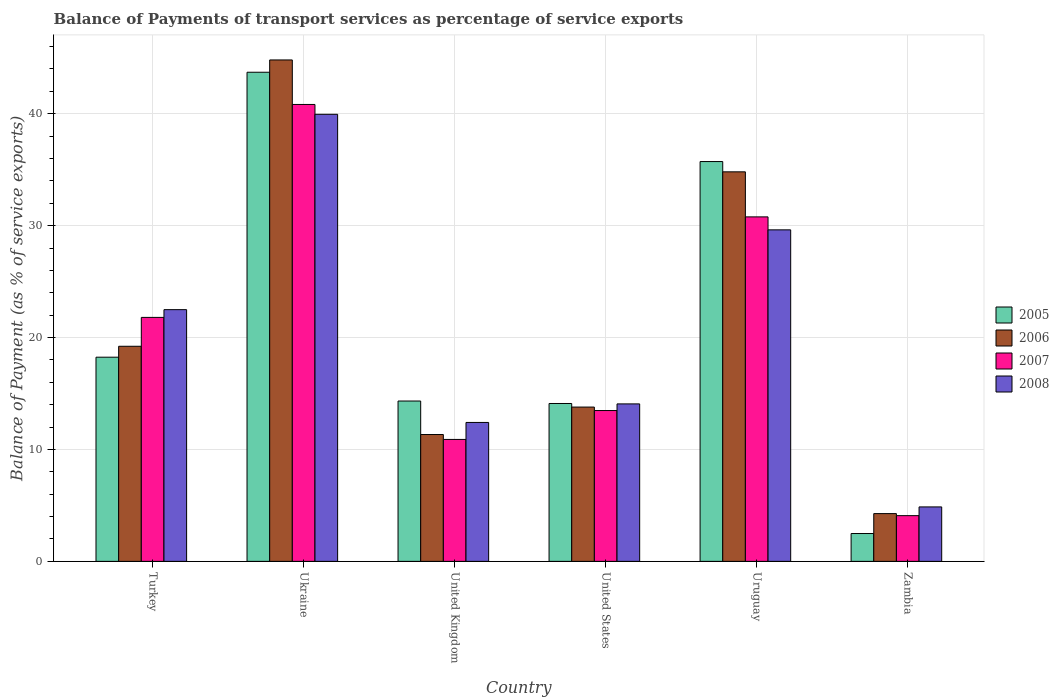How many different coloured bars are there?
Make the answer very short. 4. Are the number of bars on each tick of the X-axis equal?
Offer a very short reply. Yes. How many bars are there on the 5th tick from the left?
Provide a succinct answer. 4. How many bars are there on the 5th tick from the right?
Your answer should be compact. 4. What is the label of the 3rd group of bars from the left?
Your answer should be very brief. United Kingdom. In how many cases, is the number of bars for a given country not equal to the number of legend labels?
Offer a terse response. 0. What is the balance of payments of transport services in 2007 in United States?
Provide a short and direct response. 13.48. Across all countries, what is the maximum balance of payments of transport services in 2006?
Keep it short and to the point. 44.81. Across all countries, what is the minimum balance of payments of transport services in 2005?
Give a very brief answer. 2.49. In which country was the balance of payments of transport services in 2006 maximum?
Offer a very short reply. Ukraine. In which country was the balance of payments of transport services in 2008 minimum?
Keep it short and to the point. Zambia. What is the total balance of payments of transport services in 2006 in the graph?
Offer a very short reply. 128.23. What is the difference between the balance of payments of transport services in 2007 in Uruguay and that in Zambia?
Provide a short and direct response. 26.7. What is the difference between the balance of payments of transport services in 2008 in Turkey and the balance of payments of transport services in 2007 in United States?
Offer a terse response. 9.02. What is the average balance of payments of transport services in 2008 per country?
Offer a very short reply. 20.57. What is the difference between the balance of payments of transport services of/in 2008 and balance of payments of transport services of/in 2006 in Zambia?
Ensure brevity in your answer.  0.6. What is the ratio of the balance of payments of transport services in 2008 in United Kingdom to that in Zambia?
Make the answer very short. 2.55. What is the difference between the highest and the second highest balance of payments of transport services in 2005?
Provide a short and direct response. 17.48. What is the difference between the highest and the lowest balance of payments of transport services in 2005?
Ensure brevity in your answer.  41.22. In how many countries, is the balance of payments of transport services in 2007 greater than the average balance of payments of transport services in 2007 taken over all countries?
Offer a very short reply. 3. Is it the case that in every country, the sum of the balance of payments of transport services in 2005 and balance of payments of transport services in 2007 is greater than the sum of balance of payments of transport services in 2006 and balance of payments of transport services in 2008?
Keep it short and to the point. No. What does the 3rd bar from the right in Zambia represents?
Keep it short and to the point. 2006. How many bars are there?
Make the answer very short. 24. Are all the bars in the graph horizontal?
Give a very brief answer. No. Where does the legend appear in the graph?
Provide a succinct answer. Center right. How many legend labels are there?
Make the answer very short. 4. How are the legend labels stacked?
Make the answer very short. Vertical. What is the title of the graph?
Make the answer very short. Balance of Payments of transport services as percentage of service exports. What is the label or title of the Y-axis?
Your answer should be very brief. Balance of Payment (as % of service exports). What is the Balance of Payment (as % of service exports) in 2005 in Turkey?
Ensure brevity in your answer.  18.24. What is the Balance of Payment (as % of service exports) of 2006 in Turkey?
Your answer should be very brief. 19.22. What is the Balance of Payment (as % of service exports) in 2007 in Turkey?
Keep it short and to the point. 21.8. What is the Balance of Payment (as % of service exports) of 2008 in Turkey?
Provide a succinct answer. 22.49. What is the Balance of Payment (as % of service exports) in 2005 in Ukraine?
Make the answer very short. 43.71. What is the Balance of Payment (as % of service exports) of 2006 in Ukraine?
Your response must be concise. 44.81. What is the Balance of Payment (as % of service exports) in 2007 in Ukraine?
Give a very brief answer. 40.83. What is the Balance of Payment (as % of service exports) in 2008 in Ukraine?
Make the answer very short. 39.95. What is the Balance of Payment (as % of service exports) of 2005 in United Kingdom?
Ensure brevity in your answer.  14.33. What is the Balance of Payment (as % of service exports) in 2006 in United Kingdom?
Make the answer very short. 11.33. What is the Balance of Payment (as % of service exports) in 2007 in United Kingdom?
Ensure brevity in your answer.  10.9. What is the Balance of Payment (as % of service exports) in 2008 in United Kingdom?
Your answer should be compact. 12.41. What is the Balance of Payment (as % of service exports) of 2005 in United States?
Your answer should be very brief. 14.11. What is the Balance of Payment (as % of service exports) of 2006 in United States?
Ensure brevity in your answer.  13.79. What is the Balance of Payment (as % of service exports) of 2007 in United States?
Give a very brief answer. 13.48. What is the Balance of Payment (as % of service exports) in 2008 in United States?
Your answer should be very brief. 14.07. What is the Balance of Payment (as % of service exports) of 2005 in Uruguay?
Give a very brief answer. 35.73. What is the Balance of Payment (as % of service exports) of 2006 in Uruguay?
Offer a very short reply. 34.81. What is the Balance of Payment (as % of service exports) of 2007 in Uruguay?
Your answer should be compact. 30.78. What is the Balance of Payment (as % of service exports) of 2008 in Uruguay?
Offer a terse response. 29.62. What is the Balance of Payment (as % of service exports) of 2005 in Zambia?
Keep it short and to the point. 2.49. What is the Balance of Payment (as % of service exports) in 2006 in Zambia?
Your answer should be compact. 4.27. What is the Balance of Payment (as % of service exports) in 2007 in Zambia?
Your response must be concise. 4.08. What is the Balance of Payment (as % of service exports) of 2008 in Zambia?
Ensure brevity in your answer.  4.87. Across all countries, what is the maximum Balance of Payment (as % of service exports) of 2005?
Offer a terse response. 43.71. Across all countries, what is the maximum Balance of Payment (as % of service exports) in 2006?
Make the answer very short. 44.81. Across all countries, what is the maximum Balance of Payment (as % of service exports) in 2007?
Keep it short and to the point. 40.83. Across all countries, what is the maximum Balance of Payment (as % of service exports) of 2008?
Your response must be concise. 39.95. Across all countries, what is the minimum Balance of Payment (as % of service exports) in 2005?
Make the answer very short. 2.49. Across all countries, what is the minimum Balance of Payment (as % of service exports) of 2006?
Provide a short and direct response. 4.27. Across all countries, what is the minimum Balance of Payment (as % of service exports) in 2007?
Your answer should be very brief. 4.08. Across all countries, what is the minimum Balance of Payment (as % of service exports) of 2008?
Make the answer very short. 4.87. What is the total Balance of Payment (as % of service exports) of 2005 in the graph?
Make the answer very short. 128.6. What is the total Balance of Payment (as % of service exports) of 2006 in the graph?
Offer a terse response. 128.23. What is the total Balance of Payment (as % of service exports) in 2007 in the graph?
Give a very brief answer. 121.87. What is the total Balance of Payment (as % of service exports) in 2008 in the graph?
Your answer should be compact. 123.42. What is the difference between the Balance of Payment (as % of service exports) in 2005 in Turkey and that in Ukraine?
Offer a very short reply. -25.46. What is the difference between the Balance of Payment (as % of service exports) of 2006 in Turkey and that in Ukraine?
Provide a short and direct response. -25.59. What is the difference between the Balance of Payment (as % of service exports) in 2007 in Turkey and that in Ukraine?
Ensure brevity in your answer.  -19.03. What is the difference between the Balance of Payment (as % of service exports) in 2008 in Turkey and that in Ukraine?
Keep it short and to the point. -17.46. What is the difference between the Balance of Payment (as % of service exports) in 2005 in Turkey and that in United Kingdom?
Keep it short and to the point. 3.92. What is the difference between the Balance of Payment (as % of service exports) in 2006 in Turkey and that in United Kingdom?
Your response must be concise. 7.89. What is the difference between the Balance of Payment (as % of service exports) in 2007 in Turkey and that in United Kingdom?
Make the answer very short. 10.9. What is the difference between the Balance of Payment (as % of service exports) in 2008 in Turkey and that in United Kingdom?
Offer a terse response. 10.08. What is the difference between the Balance of Payment (as % of service exports) of 2005 in Turkey and that in United States?
Ensure brevity in your answer.  4.14. What is the difference between the Balance of Payment (as % of service exports) of 2006 in Turkey and that in United States?
Keep it short and to the point. 5.43. What is the difference between the Balance of Payment (as % of service exports) of 2007 in Turkey and that in United States?
Provide a succinct answer. 8.32. What is the difference between the Balance of Payment (as % of service exports) of 2008 in Turkey and that in United States?
Keep it short and to the point. 8.42. What is the difference between the Balance of Payment (as % of service exports) of 2005 in Turkey and that in Uruguay?
Offer a very short reply. -17.48. What is the difference between the Balance of Payment (as % of service exports) in 2006 in Turkey and that in Uruguay?
Give a very brief answer. -15.59. What is the difference between the Balance of Payment (as % of service exports) of 2007 in Turkey and that in Uruguay?
Give a very brief answer. -8.98. What is the difference between the Balance of Payment (as % of service exports) of 2008 in Turkey and that in Uruguay?
Your answer should be compact. -7.13. What is the difference between the Balance of Payment (as % of service exports) of 2005 in Turkey and that in Zambia?
Your answer should be compact. 15.76. What is the difference between the Balance of Payment (as % of service exports) of 2006 in Turkey and that in Zambia?
Provide a succinct answer. 14.95. What is the difference between the Balance of Payment (as % of service exports) of 2007 in Turkey and that in Zambia?
Make the answer very short. 17.72. What is the difference between the Balance of Payment (as % of service exports) of 2008 in Turkey and that in Zambia?
Provide a short and direct response. 17.63. What is the difference between the Balance of Payment (as % of service exports) in 2005 in Ukraine and that in United Kingdom?
Provide a succinct answer. 29.38. What is the difference between the Balance of Payment (as % of service exports) of 2006 in Ukraine and that in United Kingdom?
Provide a succinct answer. 33.47. What is the difference between the Balance of Payment (as % of service exports) of 2007 in Ukraine and that in United Kingdom?
Offer a terse response. 29.93. What is the difference between the Balance of Payment (as % of service exports) of 2008 in Ukraine and that in United Kingdom?
Provide a short and direct response. 27.54. What is the difference between the Balance of Payment (as % of service exports) of 2005 in Ukraine and that in United States?
Offer a terse response. 29.6. What is the difference between the Balance of Payment (as % of service exports) of 2006 in Ukraine and that in United States?
Offer a very short reply. 31.02. What is the difference between the Balance of Payment (as % of service exports) in 2007 in Ukraine and that in United States?
Make the answer very short. 27.35. What is the difference between the Balance of Payment (as % of service exports) of 2008 in Ukraine and that in United States?
Your response must be concise. 25.88. What is the difference between the Balance of Payment (as % of service exports) in 2005 in Ukraine and that in Uruguay?
Your response must be concise. 7.98. What is the difference between the Balance of Payment (as % of service exports) of 2006 in Ukraine and that in Uruguay?
Your response must be concise. 10. What is the difference between the Balance of Payment (as % of service exports) of 2007 in Ukraine and that in Uruguay?
Provide a succinct answer. 10.05. What is the difference between the Balance of Payment (as % of service exports) in 2008 in Ukraine and that in Uruguay?
Give a very brief answer. 10.32. What is the difference between the Balance of Payment (as % of service exports) of 2005 in Ukraine and that in Zambia?
Offer a terse response. 41.22. What is the difference between the Balance of Payment (as % of service exports) in 2006 in Ukraine and that in Zambia?
Give a very brief answer. 40.54. What is the difference between the Balance of Payment (as % of service exports) of 2007 in Ukraine and that in Zambia?
Ensure brevity in your answer.  36.74. What is the difference between the Balance of Payment (as % of service exports) of 2008 in Ukraine and that in Zambia?
Ensure brevity in your answer.  35.08. What is the difference between the Balance of Payment (as % of service exports) in 2005 in United Kingdom and that in United States?
Your answer should be compact. 0.22. What is the difference between the Balance of Payment (as % of service exports) in 2006 in United Kingdom and that in United States?
Offer a very short reply. -2.45. What is the difference between the Balance of Payment (as % of service exports) of 2007 in United Kingdom and that in United States?
Your answer should be very brief. -2.58. What is the difference between the Balance of Payment (as % of service exports) of 2008 in United Kingdom and that in United States?
Offer a terse response. -1.66. What is the difference between the Balance of Payment (as % of service exports) in 2005 in United Kingdom and that in Uruguay?
Provide a succinct answer. -21.4. What is the difference between the Balance of Payment (as % of service exports) in 2006 in United Kingdom and that in Uruguay?
Give a very brief answer. -23.47. What is the difference between the Balance of Payment (as % of service exports) of 2007 in United Kingdom and that in Uruguay?
Your answer should be compact. -19.89. What is the difference between the Balance of Payment (as % of service exports) of 2008 in United Kingdom and that in Uruguay?
Provide a short and direct response. -17.21. What is the difference between the Balance of Payment (as % of service exports) in 2005 in United Kingdom and that in Zambia?
Your answer should be compact. 11.84. What is the difference between the Balance of Payment (as % of service exports) in 2006 in United Kingdom and that in Zambia?
Offer a terse response. 7.07. What is the difference between the Balance of Payment (as % of service exports) of 2007 in United Kingdom and that in Zambia?
Your answer should be very brief. 6.81. What is the difference between the Balance of Payment (as % of service exports) in 2008 in United Kingdom and that in Zambia?
Ensure brevity in your answer.  7.55. What is the difference between the Balance of Payment (as % of service exports) of 2005 in United States and that in Uruguay?
Your answer should be compact. -21.62. What is the difference between the Balance of Payment (as % of service exports) of 2006 in United States and that in Uruguay?
Offer a terse response. -21.02. What is the difference between the Balance of Payment (as % of service exports) in 2007 in United States and that in Uruguay?
Offer a terse response. -17.31. What is the difference between the Balance of Payment (as % of service exports) of 2008 in United States and that in Uruguay?
Your response must be concise. -15.55. What is the difference between the Balance of Payment (as % of service exports) of 2005 in United States and that in Zambia?
Ensure brevity in your answer.  11.62. What is the difference between the Balance of Payment (as % of service exports) of 2006 in United States and that in Zambia?
Provide a short and direct response. 9.52. What is the difference between the Balance of Payment (as % of service exports) in 2007 in United States and that in Zambia?
Your response must be concise. 9.39. What is the difference between the Balance of Payment (as % of service exports) of 2008 in United States and that in Zambia?
Give a very brief answer. 9.2. What is the difference between the Balance of Payment (as % of service exports) in 2005 in Uruguay and that in Zambia?
Ensure brevity in your answer.  33.24. What is the difference between the Balance of Payment (as % of service exports) in 2006 in Uruguay and that in Zambia?
Your answer should be very brief. 30.54. What is the difference between the Balance of Payment (as % of service exports) of 2007 in Uruguay and that in Zambia?
Your answer should be very brief. 26.7. What is the difference between the Balance of Payment (as % of service exports) of 2008 in Uruguay and that in Zambia?
Keep it short and to the point. 24.76. What is the difference between the Balance of Payment (as % of service exports) of 2005 in Turkey and the Balance of Payment (as % of service exports) of 2006 in Ukraine?
Provide a succinct answer. -26.56. What is the difference between the Balance of Payment (as % of service exports) of 2005 in Turkey and the Balance of Payment (as % of service exports) of 2007 in Ukraine?
Keep it short and to the point. -22.58. What is the difference between the Balance of Payment (as % of service exports) of 2005 in Turkey and the Balance of Payment (as % of service exports) of 2008 in Ukraine?
Offer a terse response. -21.7. What is the difference between the Balance of Payment (as % of service exports) in 2006 in Turkey and the Balance of Payment (as % of service exports) in 2007 in Ukraine?
Your answer should be compact. -21.61. What is the difference between the Balance of Payment (as % of service exports) in 2006 in Turkey and the Balance of Payment (as % of service exports) in 2008 in Ukraine?
Make the answer very short. -20.73. What is the difference between the Balance of Payment (as % of service exports) in 2007 in Turkey and the Balance of Payment (as % of service exports) in 2008 in Ukraine?
Make the answer very short. -18.15. What is the difference between the Balance of Payment (as % of service exports) of 2005 in Turkey and the Balance of Payment (as % of service exports) of 2006 in United Kingdom?
Make the answer very short. 6.91. What is the difference between the Balance of Payment (as % of service exports) in 2005 in Turkey and the Balance of Payment (as % of service exports) in 2007 in United Kingdom?
Provide a succinct answer. 7.35. What is the difference between the Balance of Payment (as % of service exports) in 2005 in Turkey and the Balance of Payment (as % of service exports) in 2008 in United Kingdom?
Provide a short and direct response. 5.83. What is the difference between the Balance of Payment (as % of service exports) of 2006 in Turkey and the Balance of Payment (as % of service exports) of 2007 in United Kingdom?
Ensure brevity in your answer.  8.32. What is the difference between the Balance of Payment (as % of service exports) of 2006 in Turkey and the Balance of Payment (as % of service exports) of 2008 in United Kingdom?
Offer a terse response. 6.81. What is the difference between the Balance of Payment (as % of service exports) in 2007 in Turkey and the Balance of Payment (as % of service exports) in 2008 in United Kingdom?
Ensure brevity in your answer.  9.39. What is the difference between the Balance of Payment (as % of service exports) in 2005 in Turkey and the Balance of Payment (as % of service exports) in 2006 in United States?
Make the answer very short. 4.46. What is the difference between the Balance of Payment (as % of service exports) of 2005 in Turkey and the Balance of Payment (as % of service exports) of 2007 in United States?
Provide a short and direct response. 4.77. What is the difference between the Balance of Payment (as % of service exports) in 2005 in Turkey and the Balance of Payment (as % of service exports) in 2008 in United States?
Provide a succinct answer. 4.17. What is the difference between the Balance of Payment (as % of service exports) of 2006 in Turkey and the Balance of Payment (as % of service exports) of 2007 in United States?
Ensure brevity in your answer.  5.74. What is the difference between the Balance of Payment (as % of service exports) of 2006 in Turkey and the Balance of Payment (as % of service exports) of 2008 in United States?
Your answer should be very brief. 5.15. What is the difference between the Balance of Payment (as % of service exports) of 2007 in Turkey and the Balance of Payment (as % of service exports) of 2008 in United States?
Offer a terse response. 7.73. What is the difference between the Balance of Payment (as % of service exports) in 2005 in Turkey and the Balance of Payment (as % of service exports) in 2006 in Uruguay?
Keep it short and to the point. -16.56. What is the difference between the Balance of Payment (as % of service exports) of 2005 in Turkey and the Balance of Payment (as % of service exports) of 2007 in Uruguay?
Give a very brief answer. -12.54. What is the difference between the Balance of Payment (as % of service exports) of 2005 in Turkey and the Balance of Payment (as % of service exports) of 2008 in Uruguay?
Your answer should be compact. -11.38. What is the difference between the Balance of Payment (as % of service exports) in 2006 in Turkey and the Balance of Payment (as % of service exports) in 2007 in Uruguay?
Offer a very short reply. -11.56. What is the difference between the Balance of Payment (as % of service exports) of 2006 in Turkey and the Balance of Payment (as % of service exports) of 2008 in Uruguay?
Ensure brevity in your answer.  -10.4. What is the difference between the Balance of Payment (as % of service exports) in 2007 in Turkey and the Balance of Payment (as % of service exports) in 2008 in Uruguay?
Your answer should be compact. -7.82. What is the difference between the Balance of Payment (as % of service exports) of 2005 in Turkey and the Balance of Payment (as % of service exports) of 2006 in Zambia?
Your answer should be compact. 13.98. What is the difference between the Balance of Payment (as % of service exports) of 2005 in Turkey and the Balance of Payment (as % of service exports) of 2007 in Zambia?
Provide a succinct answer. 14.16. What is the difference between the Balance of Payment (as % of service exports) in 2005 in Turkey and the Balance of Payment (as % of service exports) in 2008 in Zambia?
Give a very brief answer. 13.38. What is the difference between the Balance of Payment (as % of service exports) of 2006 in Turkey and the Balance of Payment (as % of service exports) of 2007 in Zambia?
Provide a short and direct response. 15.14. What is the difference between the Balance of Payment (as % of service exports) in 2006 in Turkey and the Balance of Payment (as % of service exports) in 2008 in Zambia?
Provide a short and direct response. 14.35. What is the difference between the Balance of Payment (as % of service exports) of 2007 in Turkey and the Balance of Payment (as % of service exports) of 2008 in Zambia?
Make the answer very short. 16.93. What is the difference between the Balance of Payment (as % of service exports) of 2005 in Ukraine and the Balance of Payment (as % of service exports) of 2006 in United Kingdom?
Your answer should be very brief. 32.37. What is the difference between the Balance of Payment (as % of service exports) in 2005 in Ukraine and the Balance of Payment (as % of service exports) in 2007 in United Kingdom?
Ensure brevity in your answer.  32.81. What is the difference between the Balance of Payment (as % of service exports) in 2005 in Ukraine and the Balance of Payment (as % of service exports) in 2008 in United Kingdom?
Make the answer very short. 31.29. What is the difference between the Balance of Payment (as % of service exports) of 2006 in Ukraine and the Balance of Payment (as % of service exports) of 2007 in United Kingdom?
Offer a terse response. 33.91. What is the difference between the Balance of Payment (as % of service exports) in 2006 in Ukraine and the Balance of Payment (as % of service exports) in 2008 in United Kingdom?
Keep it short and to the point. 32.39. What is the difference between the Balance of Payment (as % of service exports) in 2007 in Ukraine and the Balance of Payment (as % of service exports) in 2008 in United Kingdom?
Your response must be concise. 28.41. What is the difference between the Balance of Payment (as % of service exports) of 2005 in Ukraine and the Balance of Payment (as % of service exports) of 2006 in United States?
Give a very brief answer. 29.92. What is the difference between the Balance of Payment (as % of service exports) in 2005 in Ukraine and the Balance of Payment (as % of service exports) in 2007 in United States?
Your answer should be very brief. 30.23. What is the difference between the Balance of Payment (as % of service exports) in 2005 in Ukraine and the Balance of Payment (as % of service exports) in 2008 in United States?
Your response must be concise. 29.64. What is the difference between the Balance of Payment (as % of service exports) in 2006 in Ukraine and the Balance of Payment (as % of service exports) in 2007 in United States?
Ensure brevity in your answer.  31.33. What is the difference between the Balance of Payment (as % of service exports) of 2006 in Ukraine and the Balance of Payment (as % of service exports) of 2008 in United States?
Provide a short and direct response. 30.74. What is the difference between the Balance of Payment (as % of service exports) of 2007 in Ukraine and the Balance of Payment (as % of service exports) of 2008 in United States?
Your response must be concise. 26.76. What is the difference between the Balance of Payment (as % of service exports) in 2005 in Ukraine and the Balance of Payment (as % of service exports) in 2006 in Uruguay?
Your response must be concise. 8.9. What is the difference between the Balance of Payment (as % of service exports) of 2005 in Ukraine and the Balance of Payment (as % of service exports) of 2007 in Uruguay?
Your answer should be very brief. 12.93. What is the difference between the Balance of Payment (as % of service exports) of 2005 in Ukraine and the Balance of Payment (as % of service exports) of 2008 in Uruguay?
Your answer should be very brief. 14.08. What is the difference between the Balance of Payment (as % of service exports) of 2006 in Ukraine and the Balance of Payment (as % of service exports) of 2007 in Uruguay?
Make the answer very short. 14.02. What is the difference between the Balance of Payment (as % of service exports) of 2006 in Ukraine and the Balance of Payment (as % of service exports) of 2008 in Uruguay?
Give a very brief answer. 15.18. What is the difference between the Balance of Payment (as % of service exports) of 2007 in Ukraine and the Balance of Payment (as % of service exports) of 2008 in Uruguay?
Keep it short and to the point. 11.21. What is the difference between the Balance of Payment (as % of service exports) of 2005 in Ukraine and the Balance of Payment (as % of service exports) of 2006 in Zambia?
Ensure brevity in your answer.  39.44. What is the difference between the Balance of Payment (as % of service exports) of 2005 in Ukraine and the Balance of Payment (as % of service exports) of 2007 in Zambia?
Offer a very short reply. 39.62. What is the difference between the Balance of Payment (as % of service exports) in 2005 in Ukraine and the Balance of Payment (as % of service exports) in 2008 in Zambia?
Offer a terse response. 38.84. What is the difference between the Balance of Payment (as % of service exports) of 2006 in Ukraine and the Balance of Payment (as % of service exports) of 2007 in Zambia?
Ensure brevity in your answer.  40.72. What is the difference between the Balance of Payment (as % of service exports) of 2006 in Ukraine and the Balance of Payment (as % of service exports) of 2008 in Zambia?
Your answer should be very brief. 39.94. What is the difference between the Balance of Payment (as % of service exports) of 2007 in Ukraine and the Balance of Payment (as % of service exports) of 2008 in Zambia?
Give a very brief answer. 35.96. What is the difference between the Balance of Payment (as % of service exports) in 2005 in United Kingdom and the Balance of Payment (as % of service exports) in 2006 in United States?
Your response must be concise. 0.54. What is the difference between the Balance of Payment (as % of service exports) in 2005 in United Kingdom and the Balance of Payment (as % of service exports) in 2007 in United States?
Make the answer very short. 0.85. What is the difference between the Balance of Payment (as % of service exports) of 2005 in United Kingdom and the Balance of Payment (as % of service exports) of 2008 in United States?
Provide a succinct answer. 0.26. What is the difference between the Balance of Payment (as % of service exports) of 2006 in United Kingdom and the Balance of Payment (as % of service exports) of 2007 in United States?
Make the answer very short. -2.14. What is the difference between the Balance of Payment (as % of service exports) of 2006 in United Kingdom and the Balance of Payment (as % of service exports) of 2008 in United States?
Make the answer very short. -2.74. What is the difference between the Balance of Payment (as % of service exports) of 2007 in United Kingdom and the Balance of Payment (as % of service exports) of 2008 in United States?
Provide a succinct answer. -3.17. What is the difference between the Balance of Payment (as % of service exports) in 2005 in United Kingdom and the Balance of Payment (as % of service exports) in 2006 in Uruguay?
Make the answer very short. -20.48. What is the difference between the Balance of Payment (as % of service exports) in 2005 in United Kingdom and the Balance of Payment (as % of service exports) in 2007 in Uruguay?
Your answer should be compact. -16.45. What is the difference between the Balance of Payment (as % of service exports) in 2005 in United Kingdom and the Balance of Payment (as % of service exports) in 2008 in Uruguay?
Provide a succinct answer. -15.3. What is the difference between the Balance of Payment (as % of service exports) in 2006 in United Kingdom and the Balance of Payment (as % of service exports) in 2007 in Uruguay?
Ensure brevity in your answer.  -19.45. What is the difference between the Balance of Payment (as % of service exports) in 2006 in United Kingdom and the Balance of Payment (as % of service exports) in 2008 in Uruguay?
Your response must be concise. -18.29. What is the difference between the Balance of Payment (as % of service exports) in 2007 in United Kingdom and the Balance of Payment (as % of service exports) in 2008 in Uruguay?
Offer a very short reply. -18.73. What is the difference between the Balance of Payment (as % of service exports) in 2005 in United Kingdom and the Balance of Payment (as % of service exports) in 2006 in Zambia?
Your answer should be compact. 10.06. What is the difference between the Balance of Payment (as % of service exports) of 2005 in United Kingdom and the Balance of Payment (as % of service exports) of 2007 in Zambia?
Ensure brevity in your answer.  10.24. What is the difference between the Balance of Payment (as % of service exports) in 2005 in United Kingdom and the Balance of Payment (as % of service exports) in 2008 in Zambia?
Offer a terse response. 9.46. What is the difference between the Balance of Payment (as % of service exports) of 2006 in United Kingdom and the Balance of Payment (as % of service exports) of 2007 in Zambia?
Provide a succinct answer. 7.25. What is the difference between the Balance of Payment (as % of service exports) in 2006 in United Kingdom and the Balance of Payment (as % of service exports) in 2008 in Zambia?
Make the answer very short. 6.47. What is the difference between the Balance of Payment (as % of service exports) of 2007 in United Kingdom and the Balance of Payment (as % of service exports) of 2008 in Zambia?
Your answer should be very brief. 6.03. What is the difference between the Balance of Payment (as % of service exports) of 2005 in United States and the Balance of Payment (as % of service exports) of 2006 in Uruguay?
Your answer should be very brief. -20.7. What is the difference between the Balance of Payment (as % of service exports) of 2005 in United States and the Balance of Payment (as % of service exports) of 2007 in Uruguay?
Give a very brief answer. -16.68. What is the difference between the Balance of Payment (as % of service exports) of 2005 in United States and the Balance of Payment (as % of service exports) of 2008 in Uruguay?
Make the answer very short. -15.52. What is the difference between the Balance of Payment (as % of service exports) in 2006 in United States and the Balance of Payment (as % of service exports) in 2007 in Uruguay?
Your answer should be compact. -16.99. What is the difference between the Balance of Payment (as % of service exports) in 2006 in United States and the Balance of Payment (as % of service exports) in 2008 in Uruguay?
Your response must be concise. -15.84. What is the difference between the Balance of Payment (as % of service exports) in 2007 in United States and the Balance of Payment (as % of service exports) in 2008 in Uruguay?
Offer a very short reply. -16.15. What is the difference between the Balance of Payment (as % of service exports) in 2005 in United States and the Balance of Payment (as % of service exports) in 2006 in Zambia?
Offer a terse response. 9.84. What is the difference between the Balance of Payment (as % of service exports) in 2005 in United States and the Balance of Payment (as % of service exports) in 2007 in Zambia?
Keep it short and to the point. 10.02. What is the difference between the Balance of Payment (as % of service exports) in 2005 in United States and the Balance of Payment (as % of service exports) in 2008 in Zambia?
Offer a terse response. 9.24. What is the difference between the Balance of Payment (as % of service exports) in 2006 in United States and the Balance of Payment (as % of service exports) in 2007 in Zambia?
Ensure brevity in your answer.  9.7. What is the difference between the Balance of Payment (as % of service exports) of 2006 in United States and the Balance of Payment (as % of service exports) of 2008 in Zambia?
Provide a succinct answer. 8.92. What is the difference between the Balance of Payment (as % of service exports) of 2007 in United States and the Balance of Payment (as % of service exports) of 2008 in Zambia?
Offer a terse response. 8.61. What is the difference between the Balance of Payment (as % of service exports) in 2005 in Uruguay and the Balance of Payment (as % of service exports) in 2006 in Zambia?
Make the answer very short. 31.46. What is the difference between the Balance of Payment (as % of service exports) of 2005 in Uruguay and the Balance of Payment (as % of service exports) of 2007 in Zambia?
Keep it short and to the point. 31.64. What is the difference between the Balance of Payment (as % of service exports) of 2005 in Uruguay and the Balance of Payment (as % of service exports) of 2008 in Zambia?
Your answer should be compact. 30.86. What is the difference between the Balance of Payment (as % of service exports) of 2006 in Uruguay and the Balance of Payment (as % of service exports) of 2007 in Zambia?
Your answer should be compact. 30.72. What is the difference between the Balance of Payment (as % of service exports) of 2006 in Uruguay and the Balance of Payment (as % of service exports) of 2008 in Zambia?
Give a very brief answer. 29.94. What is the difference between the Balance of Payment (as % of service exports) of 2007 in Uruguay and the Balance of Payment (as % of service exports) of 2008 in Zambia?
Keep it short and to the point. 25.92. What is the average Balance of Payment (as % of service exports) of 2005 per country?
Your answer should be very brief. 21.43. What is the average Balance of Payment (as % of service exports) of 2006 per country?
Ensure brevity in your answer.  21.37. What is the average Balance of Payment (as % of service exports) in 2007 per country?
Your answer should be very brief. 20.31. What is the average Balance of Payment (as % of service exports) of 2008 per country?
Ensure brevity in your answer.  20.57. What is the difference between the Balance of Payment (as % of service exports) of 2005 and Balance of Payment (as % of service exports) of 2006 in Turkey?
Your response must be concise. -0.98. What is the difference between the Balance of Payment (as % of service exports) of 2005 and Balance of Payment (as % of service exports) of 2007 in Turkey?
Offer a terse response. -3.56. What is the difference between the Balance of Payment (as % of service exports) in 2005 and Balance of Payment (as % of service exports) in 2008 in Turkey?
Ensure brevity in your answer.  -4.25. What is the difference between the Balance of Payment (as % of service exports) in 2006 and Balance of Payment (as % of service exports) in 2007 in Turkey?
Provide a succinct answer. -2.58. What is the difference between the Balance of Payment (as % of service exports) in 2006 and Balance of Payment (as % of service exports) in 2008 in Turkey?
Offer a terse response. -3.27. What is the difference between the Balance of Payment (as % of service exports) of 2007 and Balance of Payment (as % of service exports) of 2008 in Turkey?
Give a very brief answer. -0.69. What is the difference between the Balance of Payment (as % of service exports) in 2005 and Balance of Payment (as % of service exports) in 2006 in Ukraine?
Your answer should be very brief. -1.1. What is the difference between the Balance of Payment (as % of service exports) in 2005 and Balance of Payment (as % of service exports) in 2007 in Ukraine?
Your answer should be compact. 2.88. What is the difference between the Balance of Payment (as % of service exports) of 2005 and Balance of Payment (as % of service exports) of 2008 in Ukraine?
Your answer should be compact. 3.76. What is the difference between the Balance of Payment (as % of service exports) of 2006 and Balance of Payment (as % of service exports) of 2007 in Ukraine?
Give a very brief answer. 3.98. What is the difference between the Balance of Payment (as % of service exports) of 2006 and Balance of Payment (as % of service exports) of 2008 in Ukraine?
Offer a terse response. 4.86. What is the difference between the Balance of Payment (as % of service exports) of 2007 and Balance of Payment (as % of service exports) of 2008 in Ukraine?
Provide a succinct answer. 0.88. What is the difference between the Balance of Payment (as % of service exports) of 2005 and Balance of Payment (as % of service exports) of 2006 in United Kingdom?
Offer a very short reply. 2.99. What is the difference between the Balance of Payment (as % of service exports) in 2005 and Balance of Payment (as % of service exports) in 2007 in United Kingdom?
Your response must be concise. 3.43. What is the difference between the Balance of Payment (as % of service exports) in 2005 and Balance of Payment (as % of service exports) in 2008 in United Kingdom?
Your response must be concise. 1.91. What is the difference between the Balance of Payment (as % of service exports) in 2006 and Balance of Payment (as % of service exports) in 2007 in United Kingdom?
Provide a succinct answer. 0.44. What is the difference between the Balance of Payment (as % of service exports) of 2006 and Balance of Payment (as % of service exports) of 2008 in United Kingdom?
Offer a terse response. -1.08. What is the difference between the Balance of Payment (as % of service exports) of 2007 and Balance of Payment (as % of service exports) of 2008 in United Kingdom?
Make the answer very short. -1.52. What is the difference between the Balance of Payment (as % of service exports) of 2005 and Balance of Payment (as % of service exports) of 2006 in United States?
Your answer should be compact. 0.32. What is the difference between the Balance of Payment (as % of service exports) in 2005 and Balance of Payment (as % of service exports) in 2007 in United States?
Provide a succinct answer. 0.63. What is the difference between the Balance of Payment (as % of service exports) in 2005 and Balance of Payment (as % of service exports) in 2008 in United States?
Offer a very short reply. 0.04. What is the difference between the Balance of Payment (as % of service exports) of 2006 and Balance of Payment (as % of service exports) of 2007 in United States?
Give a very brief answer. 0.31. What is the difference between the Balance of Payment (as % of service exports) of 2006 and Balance of Payment (as % of service exports) of 2008 in United States?
Provide a succinct answer. -0.28. What is the difference between the Balance of Payment (as % of service exports) in 2007 and Balance of Payment (as % of service exports) in 2008 in United States?
Provide a succinct answer. -0.59. What is the difference between the Balance of Payment (as % of service exports) in 2005 and Balance of Payment (as % of service exports) in 2006 in Uruguay?
Offer a terse response. 0.92. What is the difference between the Balance of Payment (as % of service exports) of 2005 and Balance of Payment (as % of service exports) of 2007 in Uruguay?
Your response must be concise. 4.94. What is the difference between the Balance of Payment (as % of service exports) of 2005 and Balance of Payment (as % of service exports) of 2008 in Uruguay?
Your response must be concise. 6.1. What is the difference between the Balance of Payment (as % of service exports) of 2006 and Balance of Payment (as % of service exports) of 2007 in Uruguay?
Ensure brevity in your answer.  4.03. What is the difference between the Balance of Payment (as % of service exports) in 2006 and Balance of Payment (as % of service exports) in 2008 in Uruguay?
Your response must be concise. 5.18. What is the difference between the Balance of Payment (as % of service exports) of 2007 and Balance of Payment (as % of service exports) of 2008 in Uruguay?
Your answer should be very brief. 1.16. What is the difference between the Balance of Payment (as % of service exports) in 2005 and Balance of Payment (as % of service exports) in 2006 in Zambia?
Offer a terse response. -1.78. What is the difference between the Balance of Payment (as % of service exports) of 2005 and Balance of Payment (as % of service exports) of 2007 in Zambia?
Give a very brief answer. -1.6. What is the difference between the Balance of Payment (as % of service exports) of 2005 and Balance of Payment (as % of service exports) of 2008 in Zambia?
Ensure brevity in your answer.  -2.38. What is the difference between the Balance of Payment (as % of service exports) of 2006 and Balance of Payment (as % of service exports) of 2007 in Zambia?
Your answer should be compact. 0.18. What is the difference between the Balance of Payment (as % of service exports) of 2006 and Balance of Payment (as % of service exports) of 2008 in Zambia?
Offer a terse response. -0.6. What is the difference between the Balance of Payment (as % of service exports) of 2007 and Balance of Payment (as % of service exports) of 2008 in Zambia?
Keep it short and to the point. -0.78. What is the ratio of the Balance of Payment (as % of service exports) of 2005 in Turkey to that in Ukraine?
Offer a very short reply. 0.42. What is the ratio of the Balance of Payment (as % of service exports) in 2006 in Turkey to that in Ukraine?
Your response must be concise. 0.43. What is the ratio of the Balance of Payment (as % of service exports) of 2007 in Turkey to that in Ukraine?
Give a very brief answer. 0.53. What is the ratio of the Balance of Payment (as % of service exports) of 2008 in Turkey to that in Ukraine?
Your response must be concise. 0.56. What is the ratio of the Balance of Payment (as % of service exports) in 2005 in Turkey to that in United Kingdom?
Offer a very short reply. 1.27. What is the ratio of the Balance of Payment (as % of service exports) of 2006 in Turkey to that in United Kingdom?
Your answer should be very brief. 1.7. What is the ratio of the Balance of Payment (as % of service exports) in 2007 in Turkey to that in United Kingdom?
Your answer should be very brief. 2. What is the ratio of the Balance of Payment (as % of service exports) in 2008 in Turkey to that in United Kingdom?
Make the answer very short. 1.81. What is the ratio of the Balance of Payment (as % of service exports) of 2005 in Turkey to that in United States?
Offer a very short reply. 1.29. What is the ratio of the Balance of Payment (as % of service exports) in 2006 in Turkey to that in United States?
Keep it short and to the point. 1.39. What is the ratio of the Balance of Payment (as % of service exports) of 2007 in Turkey to that in United States?
Your answer should be very brief. 1.62. What is the ratio of the Balance of Payment (as % of service exports) in 2008 in Turkey to that in United States?
Provide a short and direct response. 1.6. What is the ratio of the Balance of Payment (as % of service exports) of 2005 in Turkey to that in Uruguay?
Your answer should be very brief. 0.51. What is the ratio of the Balance of Payment (as % of service exports) in 2006 in Turkey to that in Uruguay?
Provide a succinct answer. 0.55. What is the ratio of the Balance of Payment (as % of service exports) of 2007 in Turkey to that in Uruguay?
Provide a succinct answer. 0.71. What is the ratio of the Balance of Payment (as % of service exports) in 2008 in Turkey to that in Uruguay?
Your response must be concise. 0.76. What is the ratio of the Balance of Payment (as % of service exports) of 2005 in Turkey to that in Zambia?
Your response must be concise. 7.33. What is the ratio of the Balance of Payment (as % of service exports) of 2006 in Turkey to that in Zambia?
Offer a very short reply. 4.5. What is the ratio of the Balance of Payment (as % of service exports) of 2007 in Turkey to that in Zambia?
Offer a terse response. 5.34. What is the ratio of the Balance of Payment (as % of service exports) in 2008 in Turkey to that in Zambia?
Your answer should be compact. 4.62. What is the ratio of the Balance of Payment (as % of service exports) in 2005 in Ukraine to that in United Kingdom?
Ensure brevity in your answer.  3.05. What is the ratio of the Balance of Payment (as % of service exports) in 2006 in Ukraine to that in United Kingdom?
Provide a short and direct response. 3.95. What is the ratio of the Balance of Payment (as % of service exports) of 2007 in Ukraine to that in United Kingdom?
Offer a very short reply. 3.75. What is the ratio of the Balance of Payment (as % of service exports) of 2008 in Ukraine to that in United Kingdom?
Offer a very short reply. 3.22. What is the ratio of the Balance of Payment (as % of service exports) in 2005 in Ukraine to that in United States?
Give a very brief answer. 3.1. What is the ratio of the Balance of Payment (as % of service exports) in 2006 in Ukraine to that in United States?
Offer a terse response. 3.25. What is the ratio of the Balance of Payment (as % of service exports) of 2007 in Ukraine to that in United States?
Your response must be concise. 3.03. What is the ratio of the Balance of Payment (as % of service exports) of 2008 in Ukraine to that in United States?
Make the answer very short. 2.84. What is the ratio of the Balance of Payment (as % of service exports) of 2005 in Ukraine to that in Uruguay?
Provide a short and direct response. 1.22. What is the ratio of the Balance of Payment (as % of service exports) of 2006 in Ukraine to that in Uruguay?
Offer a very short reply. 1.29. What is the ratio of the Balance of Payment (as % of service exports) in 2007 in Ukraine to that in Uruguay?
Make the answer very short. 1.33. What is the ratio of the Balance of Payment (as % of service exports) of 2008 in Ukraine to that in Uruguay?
Offer a terse response. 1.35. What is the ratio of the Balance of Payment (as % of service exports) of 2005 in Ukraine to that in Zambia?
Give a very brief answer. 17.57. What is the ratio of the Balance of Payment (as % of service exports) of 2006 in Ukraine to that in Zambia?
Your answer should be compact. 10.5. What is the ratio of the Balance of Payment (as % of service exports) in 2007 in Ukraine to that in Zambia?
Offer a terse response. 10. What is the ratio of the Balance of Payment (as % of service exports) in 2008 in Ukraine to that in Zambia?
Provide a short and direct response. 8.21. What is the ratio of the Balance of Payment (as % of service exports) of 2005 in United Kingdom to that in United States?
Give a very brief answer. 1.02. What is the ratio of the Balance of Payment (as % of service exports) of 2006 in United Kingdom to that in United States?
Make the answer very short. 0.82. What is the ratio of the Balance of Payment (as % of service exports) of 2007 in United Kingdom to that in United States?
Offer a very short reply. 0.81. What is the ratio of the Balance of Payment (as % of service exports) of 2008 in United Kingdom to that in United States?
Offer a terse response. 0.88. What is the ratio of the Balance of Payment (as % of service exports) in 2005 in United Kingdom to that in Uruguay?
Your answer should be compact. 0.4. What is the ratio of the Balance of Payment (as % of service exports) in 2006 in United Kingdom to that in Uruguay?
Offer a very short reply. 0.33. What is the ratio of the Balance of Payment (as % of service exports) in 2007 in United Kingdom to that in Uruguay?
Offer a terse response. 0.35. What is the ratio of the Balance of Payment (as % of service exports) in 2008 in United Kingdom to that in Uruguay?
Your response must be concise. 0.42. What is the ratio of the Balance of Payment (as % of service exports) in 2005 in United Kingdom to that in Zambia?
Your answer should be compact. 5.76. What is the ratio of the Balance of Payment (as % of service exports) of 2006 in United Kingdom to that in Zambia?
Offer a terse response. 2.66. What is the ratio of the Balance of Payment (as % of service exports) in 2007 in United Kingdom to that in Zambia?
Your answer should be very brief. 2.67. What is the ratio of the Balance of Payment (as % of service exports) of 2008 in United Kingdom to that in Zambia?
Your answer should be compact. 2.55. What is the ratio of the Balance of Payment (as % of service exports) of 2005 in United States to that in Uruguay?
Ensure brevity in your answer.  0.39. What is the ratio of the Balance of Payment (as % of service exports) in 2006 in United States to that in Uruguay?
Make the answer very short. 0.4. What is the ratio of the Balance of Payment (as % of service exports) in 2007 in United States to that in Uruguay?
Your answer should be very brief. 0.44. What is the ratio of the Balance of Payment (as % of service exports) of 2008 in United States to that in Uruguay?
Offer a terse response. 0.47. What is the ratio of the Balance of Payment (as % of service exports) of 2005 in United States to that in Zambia?
Keep it short and to the point. 5.67. What is the ratio of the Balance of Payment (as % of service exports) of 2006 in United States to that in Zambia?
Offer a terse response. 3.23. What is the ratio of the Balance of Payment (as % of service exports) in 2007 in United States to that in Zambia?
Your answer should be compact. 3.3. What is the ratio of the Balance of Payment (as % of service exports) in 2008 in United States to that in Zambia?
Your response must be concise. 2.89. What is the ratio of the Balance of Payment (as % of service exports) of 2005 in Uruguay to that in Zambia?
Your answer should be very brief. 14.36. What is the ratio of the Balance of Payment (as % of service exports) of 2006 in Uruguay to that in Zambia?
Ensure brevity in your answer.  8.15. What is the ratio of the Balance of Payment (as % of service exports) of 2007 in Uruguay to that in Zambia?
Ensure brevity in your answer.  7.54. What is the ratio of the Balance of Payment (as % of service exports) of 2008 in Uruguay to that in Zambia?
Your response must be concise. 6.09. What is the difference between the highest and the second highest Balance of Payment (as % of service exports) of 2005?
Keep it short and to the point. 7.98. What is the difference between the highest and the second highest Balance of Payment (as % of service exports) in 2006?
Offer a very short reply. 10. What is the difference between the highest and the second highest Balance of Payment (as % of service exports) in 2007?
Provide a short and direct response. 10.05. What is the difference between the highest and the second highest Balance of Payment (as % of service exports) of 2008?
Your response must be concise. 10.32. What is the difference between the highest and the lowest Balance of Payment (as % of service exports) in 2005?
Your answer should be compact. 41.22. What is the difference between the highest and the lowest Balance of Payment (as % of service exports) of 2006?
Your answer should be compact. 40.54. What is the difference between the highest and the lowest Balance of Payment (as % of service exports) in 2007?
Your response must be concise. 36.74. What is the difference between the highest and the lowest Balance of Payment (as % of service exports) in 2008?
Ensure brevity in your answer.  35.08. 